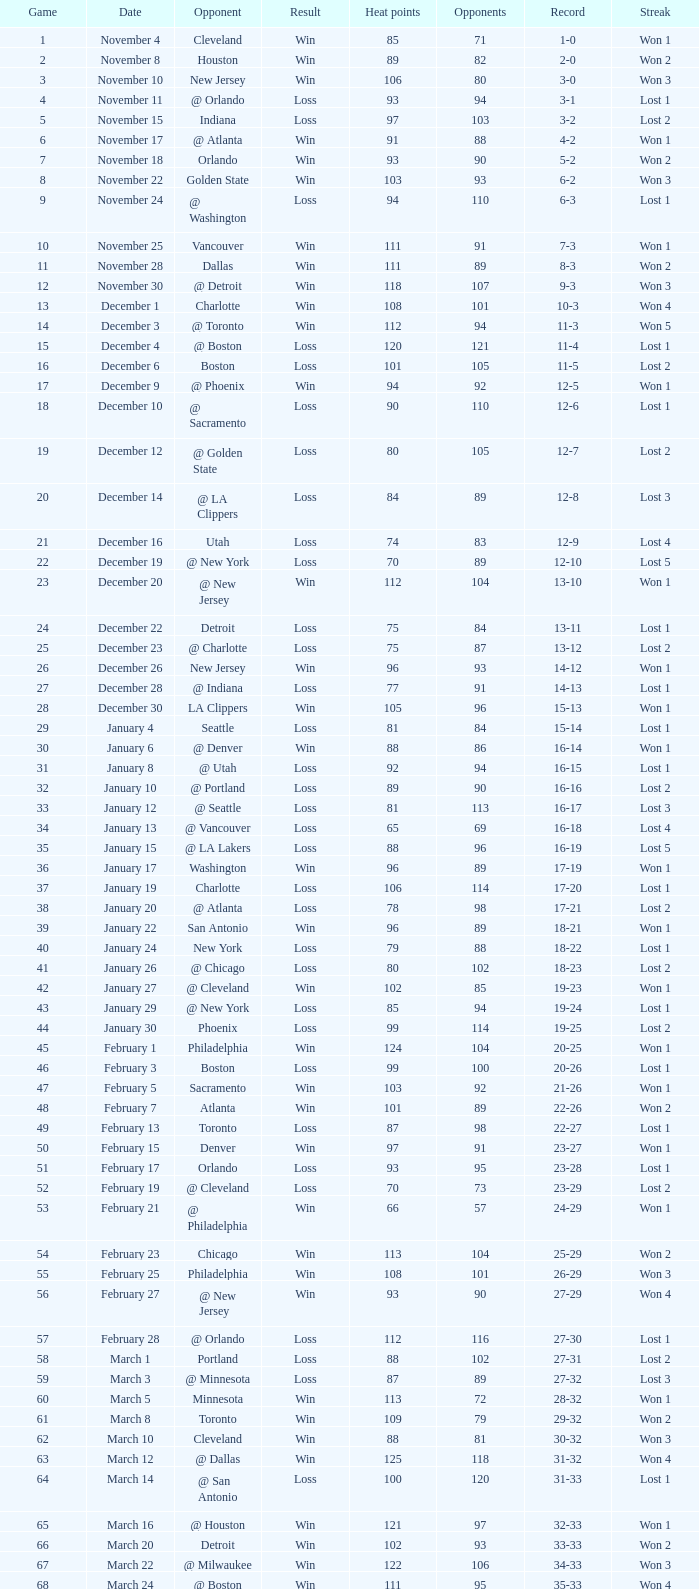What is streak, when heat score is "101", and when contest is "16"? Lost 2. 